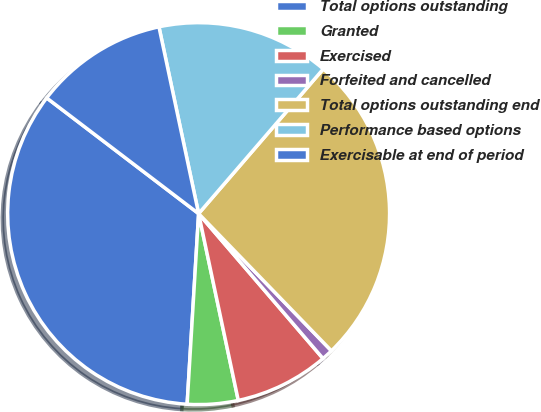Convert chart. <chart><loc_0><loc_0><loc_500><loc_500><pie_chart><fcel>Total options outstanding<fcel>Granted<fcel>Exercised<fcel>Forfeited and cancelled<fcel>Total options outstanding end<fcel>Performance based options<fcel>Exercisable at end of period<nl><fcel>34.4%<fcel>4.29%<fcel>7.96%<fcel>0.95%<fcel>26.44%<fcel>14.65%<fcel>11.31%<nl></chart> 